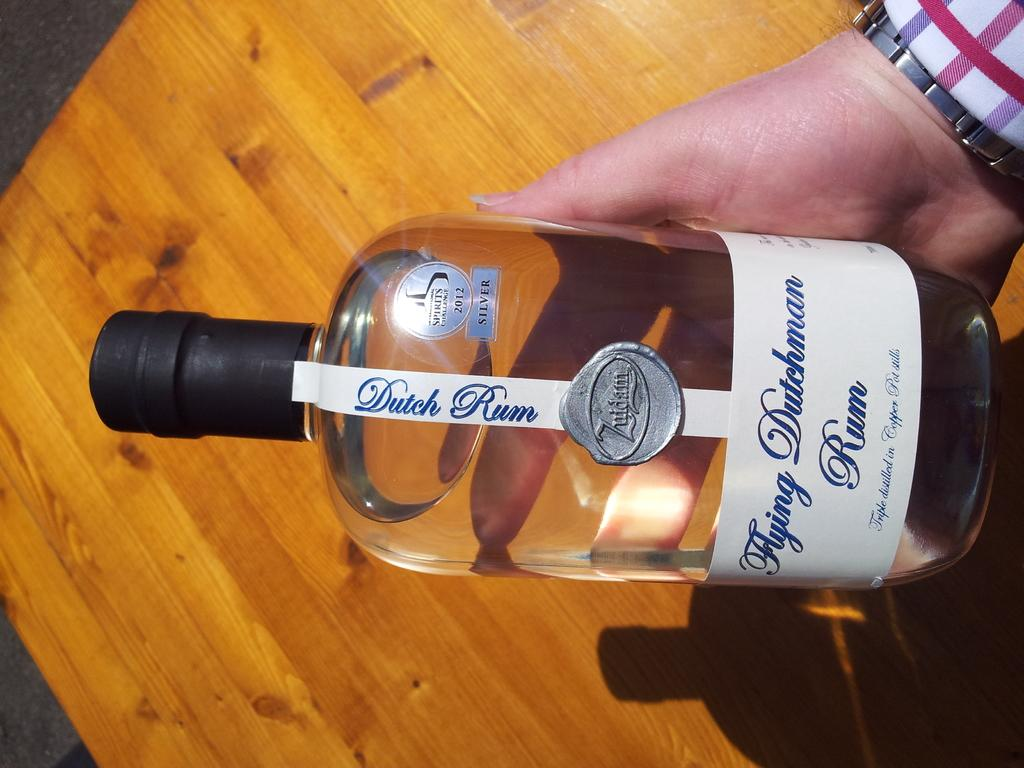<image>
Share a concise interpretation of the image provided. A hand is holding a bottle of Dutch Rum. 